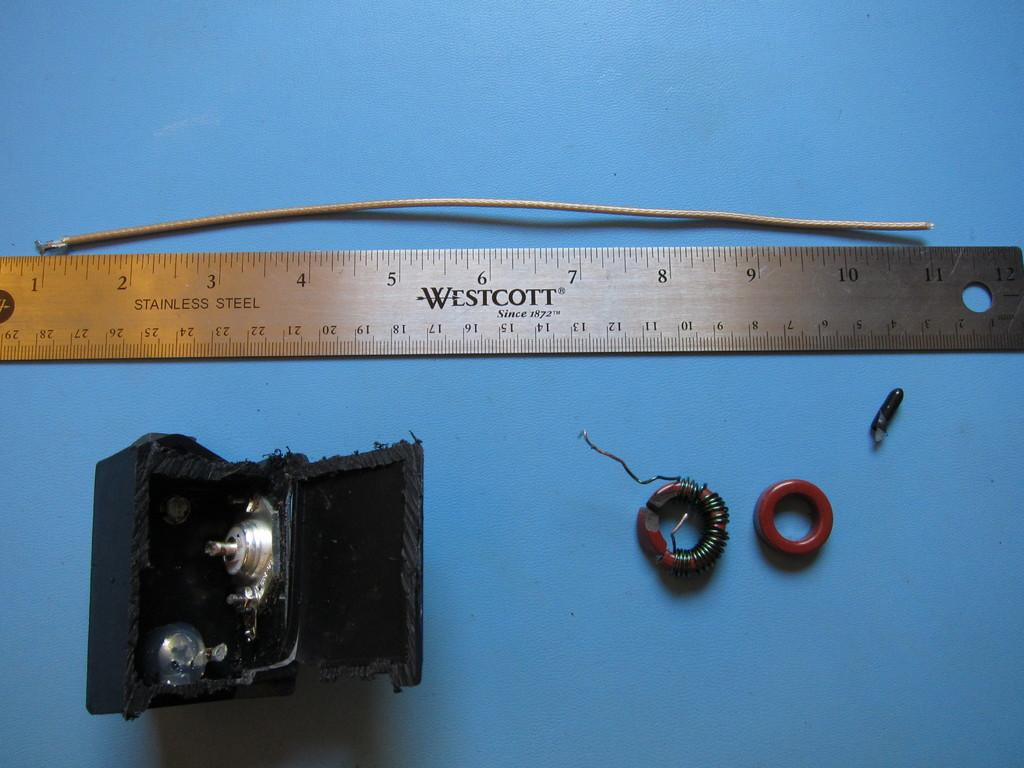<image>
Describe the image concisely. A metal Westcott ruler sits next to a piece of wire. 